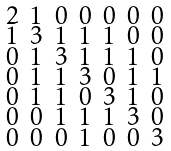Convert formula to latex. <formula><loc_0><loc_0><loc_500><loc_500>\begin{smallmatrix} 2 & 1 & 0 & 0 & 0 & 0 & 0 \\ 1 & 3 & 1 & 1 & 1 & 0 & 0 \\ 0 & 1 & 3 & 1 & 1 & 1 & 0 \\ 0 & 1 & 1 & 3 & 0 & 1 & 1 \\ 0 & 1 & 1 & 0 & 3 & 1 & 0 \\ 0 & 0 & 1 & 1 & 1 & 3 & 0 \\ 0 & 0 & 0 & 1 & 0 & 0 & 3 \end{smallmatrix}</formula> 